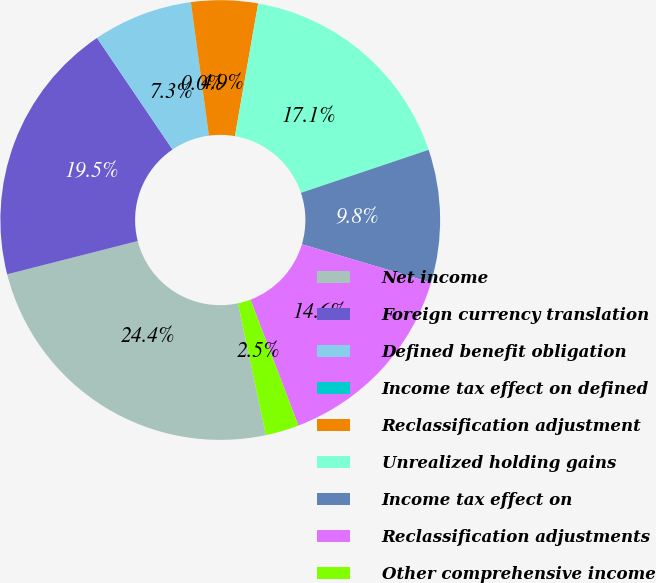<chart> <loc_0><loc_0><loc_500><loc_500><pie_chart><fcel>Net income<fcel>Foreign currency translation<fcel>Defined benefit obligation<fcel>Income tax effect on defined<fcel>Reclassification adjustment<fcel>Unrealized holding gains<fcel>Income tax effect on<fcel>Reclassification adjustments<fcel>Other comprehensive income<nl><fcel>24.36%<fcel>19.5%<fcel>7.32%<fcel>0.02%<fcel>4.89%<fcel>17.07%<fcel>9.76%<fcel>14.63%<fcel>2.45%<nl></chart> 